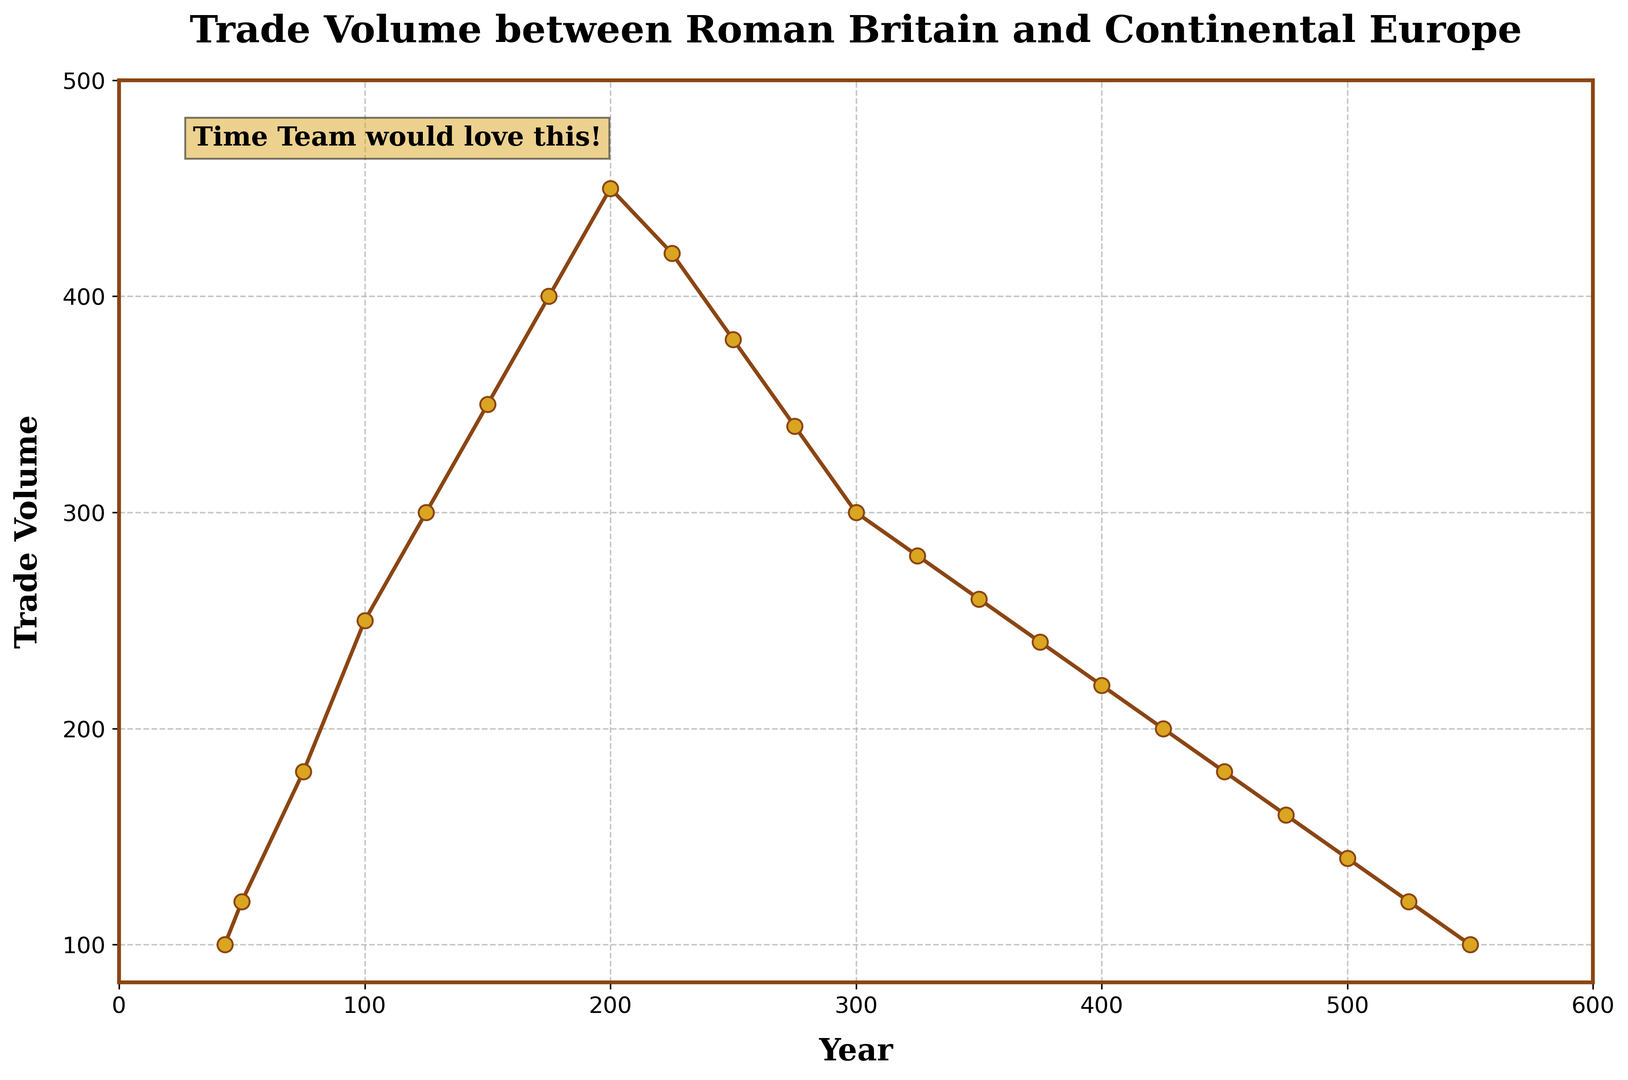What's the trade volume in the year 100? According to the plot, locate the year 100 on the x-axis and see where it meets the trade volume curve. The trade volume is indicated directly on the curve.
Answer: 250 What is the difference in trade volume between the years 75 and 200? First, find the trade volume for the years 75 and 200 on the y-axis. The trade volumes are 180 and 450 respectively. Subtract the trade volume of 75 from that of 200: 450 - 180 = 270.
Answer: 270 Which year shows a higher trade volume: 225 or 325? Locate the years 225 and 325 on the x-axis and compare their corresponding trade volumes on the y-axis. Year 225 has a trade volume of 420, whereas year 325 has a trade volume of 280.
Answer: 225 What is the average trade volume between the years 150 and 250? To find the average trade volume, sum the trade volumes for years 150, 175, 200, and 225 (350 + 400 + 450 + 420), then divide by the number of years (4). The calculation is (350 + 400 + 450 + 420) / 4 = 1620 / 4 = 405.
Answer: 405 How does the trade volume change from the year 300 to the year 350? Locate the years 300 and 350 on the x-axis and note the corresponding trade volumes. Year 300 has a trade volume of 300, while year 350 has a trade volume of 260. The trade volume decreases by 40 units (300 - 260).
Answer: Decreases by 40 What's the trend in trade volume from the year 400 to the end of the dataset? Identify the years from 400 to 550 and observe the trade volume. The trade volume decreases consistently from 220 to 100.
Answer: Decreasing What is the lowest trade volume recorded in the dataset? Scan the entire plot and identify the lowest point. The trade volume of 100 at years 43 and 550 is the lowest.
Answer: 100 In which period(s) does the trade volume remain relatively stable and why? Looking at the plot, identify periods where the trade volume shows minimal fluctuations. Between years 325 to 400, the trade volume decreases gradually, showing relative stability.
Answer: 325 to 400 What is the trade volume difference between the highest and lowest points recorded in the plot? Find the maximum trade volume (450 at year 200) and the minimum trade volume (100 at years 43 and 550). The difference is 450 - 100 = 350.
Answer: 350 Which year marks the peak in trade volume according to the figure? Examine the plot to find the highest point. The peak trade volume occurs in the year 200.
Answer: 200 